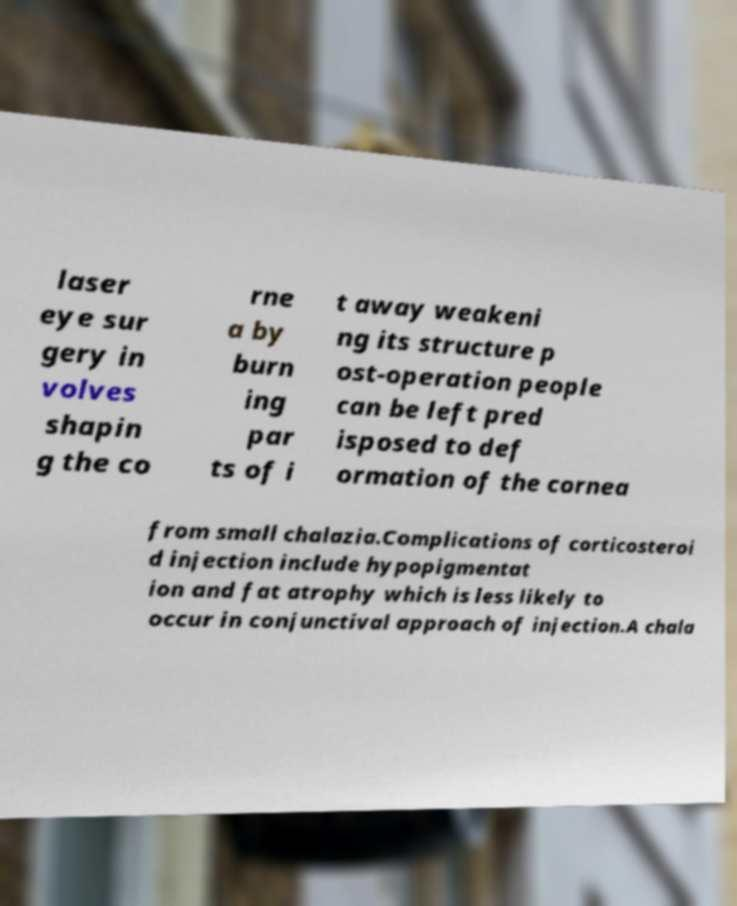What messages or text are displayed in this image? I need them in a readable, typed format. laser eye sur gery in volves shapin g the co rne a by burn ing par ts of i t away weakeni ng its structure p ost-operation people can be left pred isposed to def ormation of the cornea from small chalazia.Complications of corticosteroi d injection include hypopigmentat ion and fat atrophy which is less likely to occur in conjunctival approach of injection.A chala 